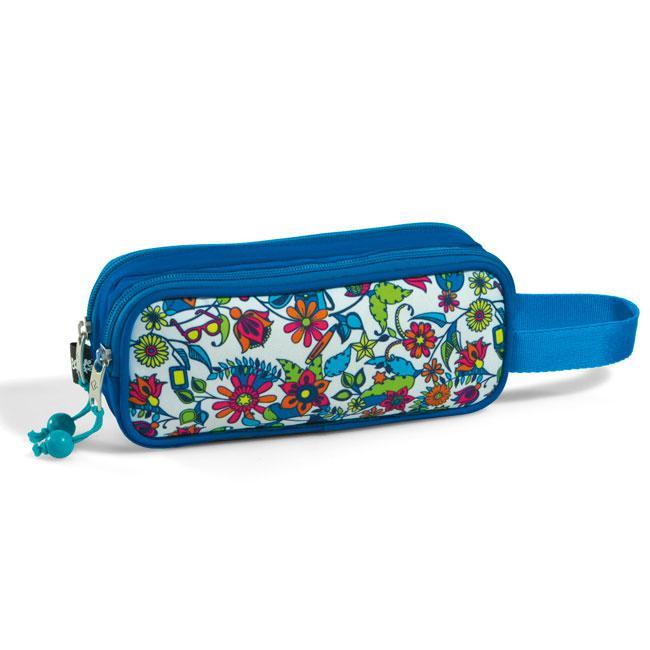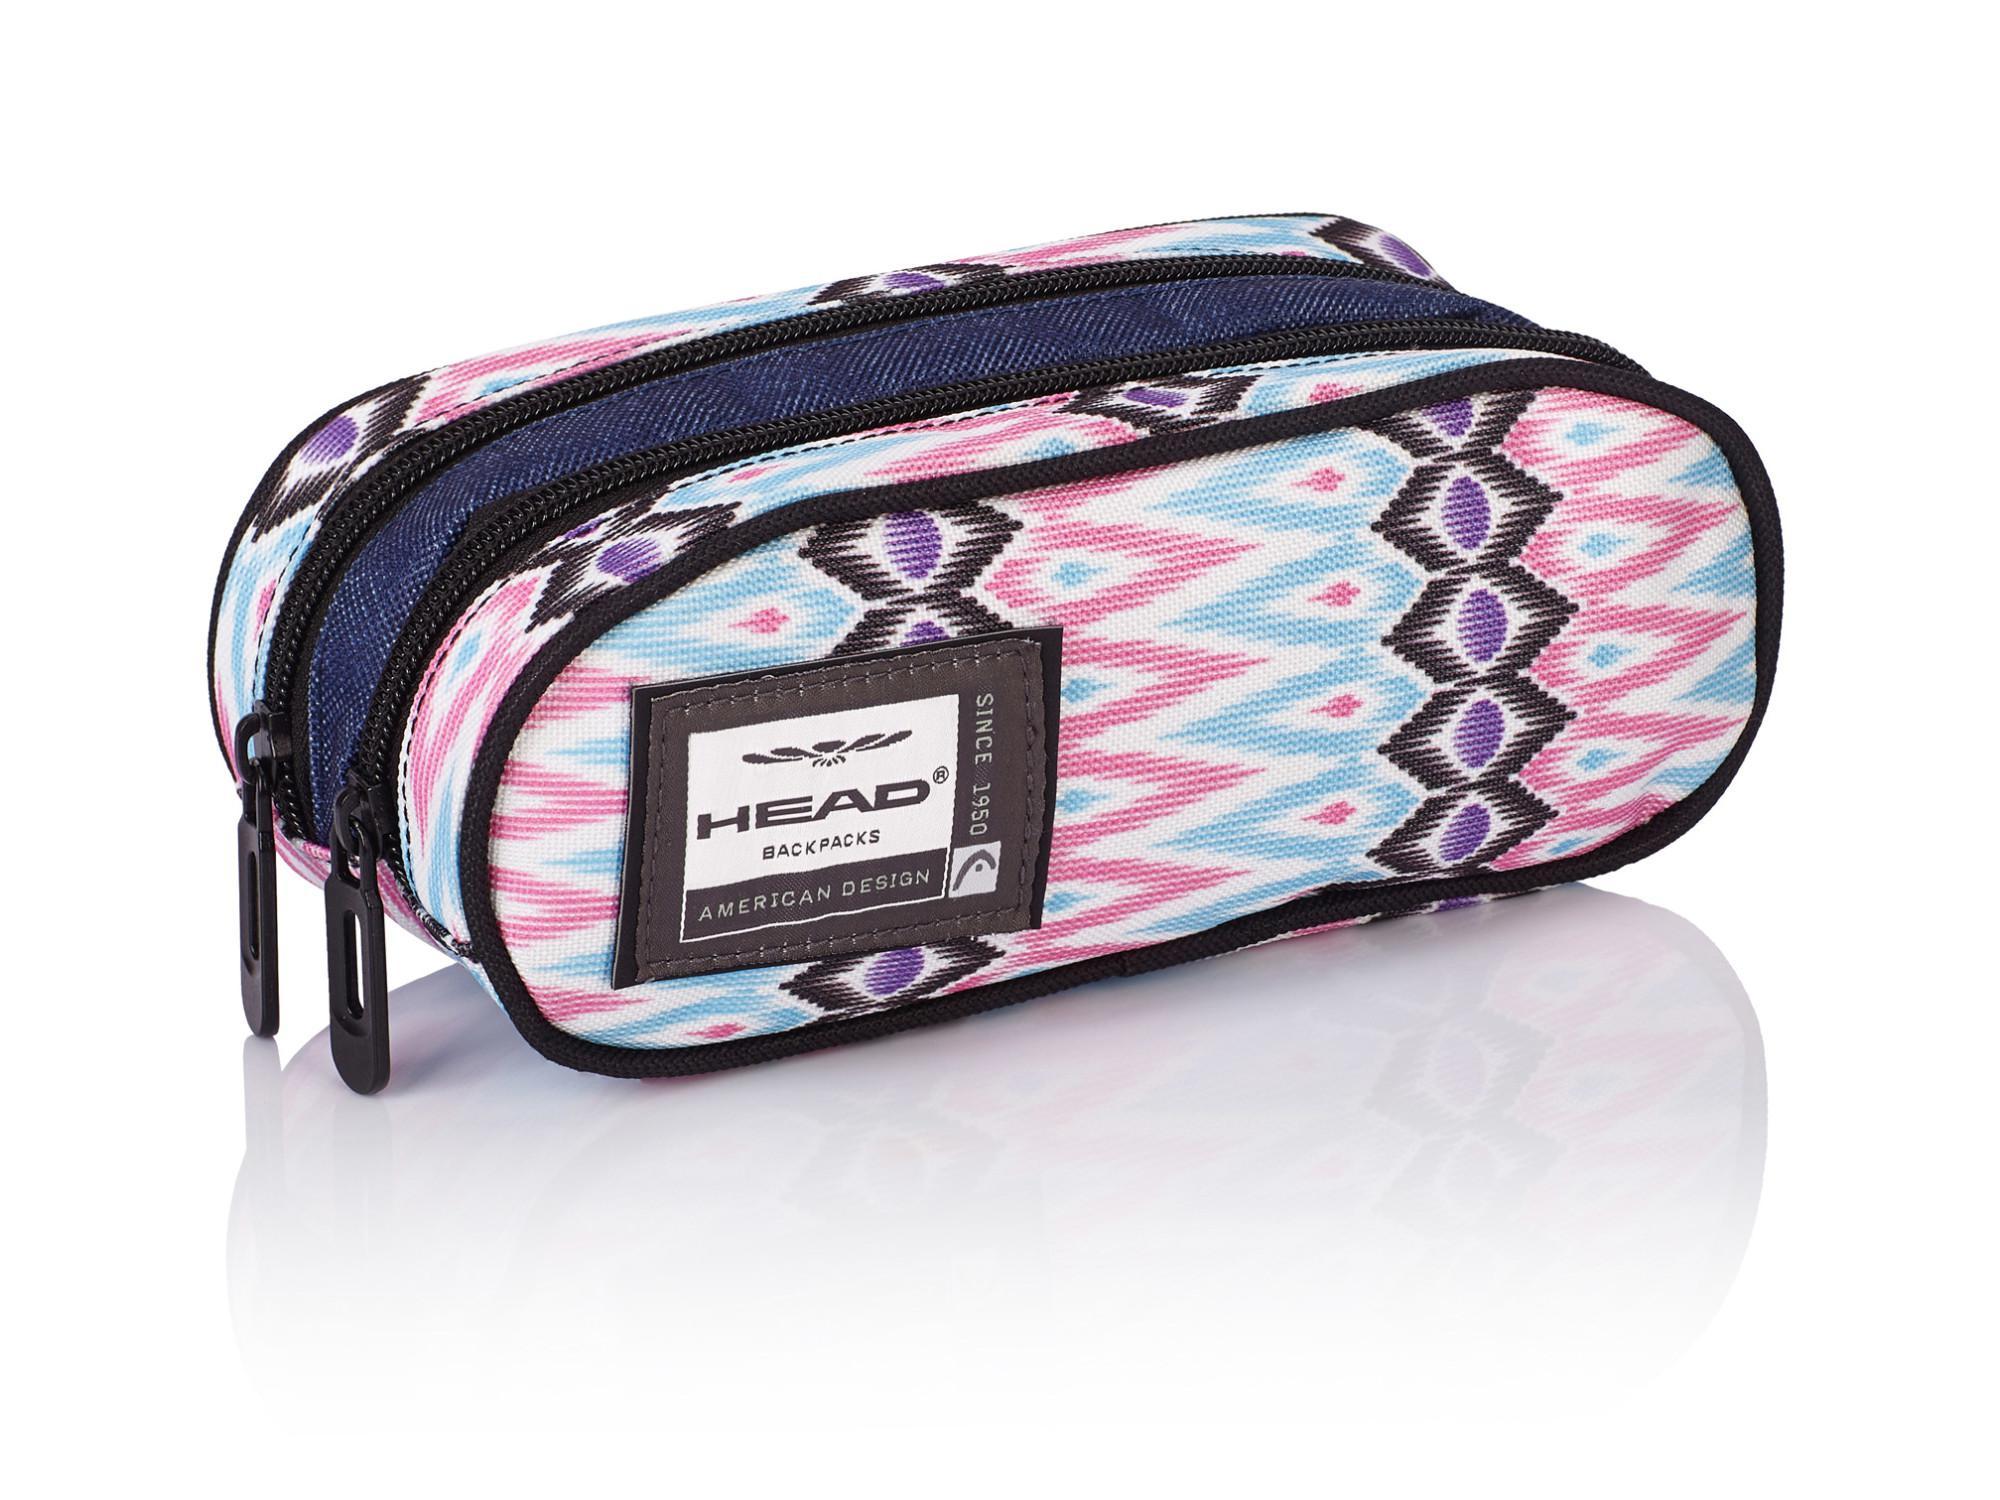The first image is the image on the left, the second image is the image on the right. Evaluate the accuracy of this statement regarding the images: "There are flowers on the case in the image on the left.". Is it true? Answer yes or no. Yes. 